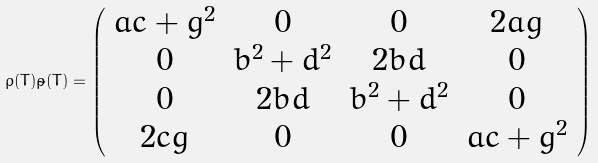<formula> <loc_0><loc_0><loc_500><loc_500>\rho ( T ) \tilde { \rho } ( T ) = \left ( \begin{array} { c c c c } a c + g ^ { 2 } & 0 & 0 & 2 a g \\ 0 & b ^ { 2 } + d ^ { 2 } & 2 b d & 0 \\ 0 & 2 b d & b ^ { 2 } + d ^ { 2 } & 0 \\ 2 c g & 0 & 0 & a c + g ^ { 2 } \end{array} \right )</formula> 